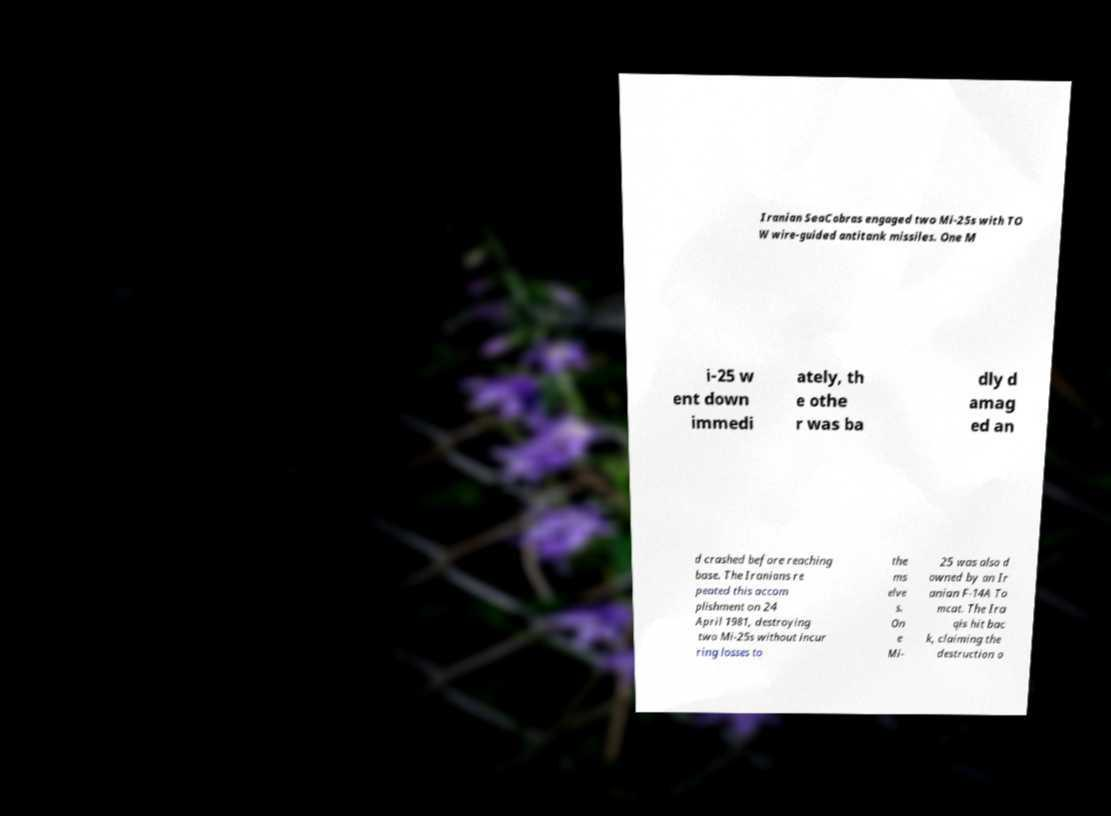I need the written content from this picture converted into text. Can you do that? Iranian SeaCobras engaged two Mi-25s with TO W wire-guided antitank missiles. One M i-25 w ent down immedi ately, th e othe r was ba dly d amag ed an d crashed before reaching base. The Iranians re peated this accom plishment on 24 April 1981, destroying two Mi-25s without incur ring losses to the ms elve s. On e Mi- 25 was also d owned by an Ir anian F-14A To mcat. The Ira qis hit bac k, claiming the destruction o 